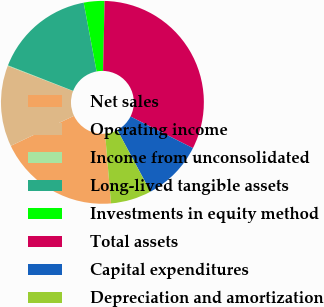Convert chart to OTSL. <chart><loc_0><loc_0><loc_500><loc_500><pie_chart><fcel>Net sales<fcel>Operating income<fcel>Income from unconsolidated<fcel>Long-lived tangible assets<fcel>Investments in equity method<fcel>Total assets<fcel>Capital expenditures<fcel>Depreciation and amortization<nl><fcel>19.3%<fcel>12.9%<fcel>0.1%<fcel>16.1%<fcel>3.3%<fcel>32.11%<fcel>9.7%<fcel>6.5%<nl></chart> 